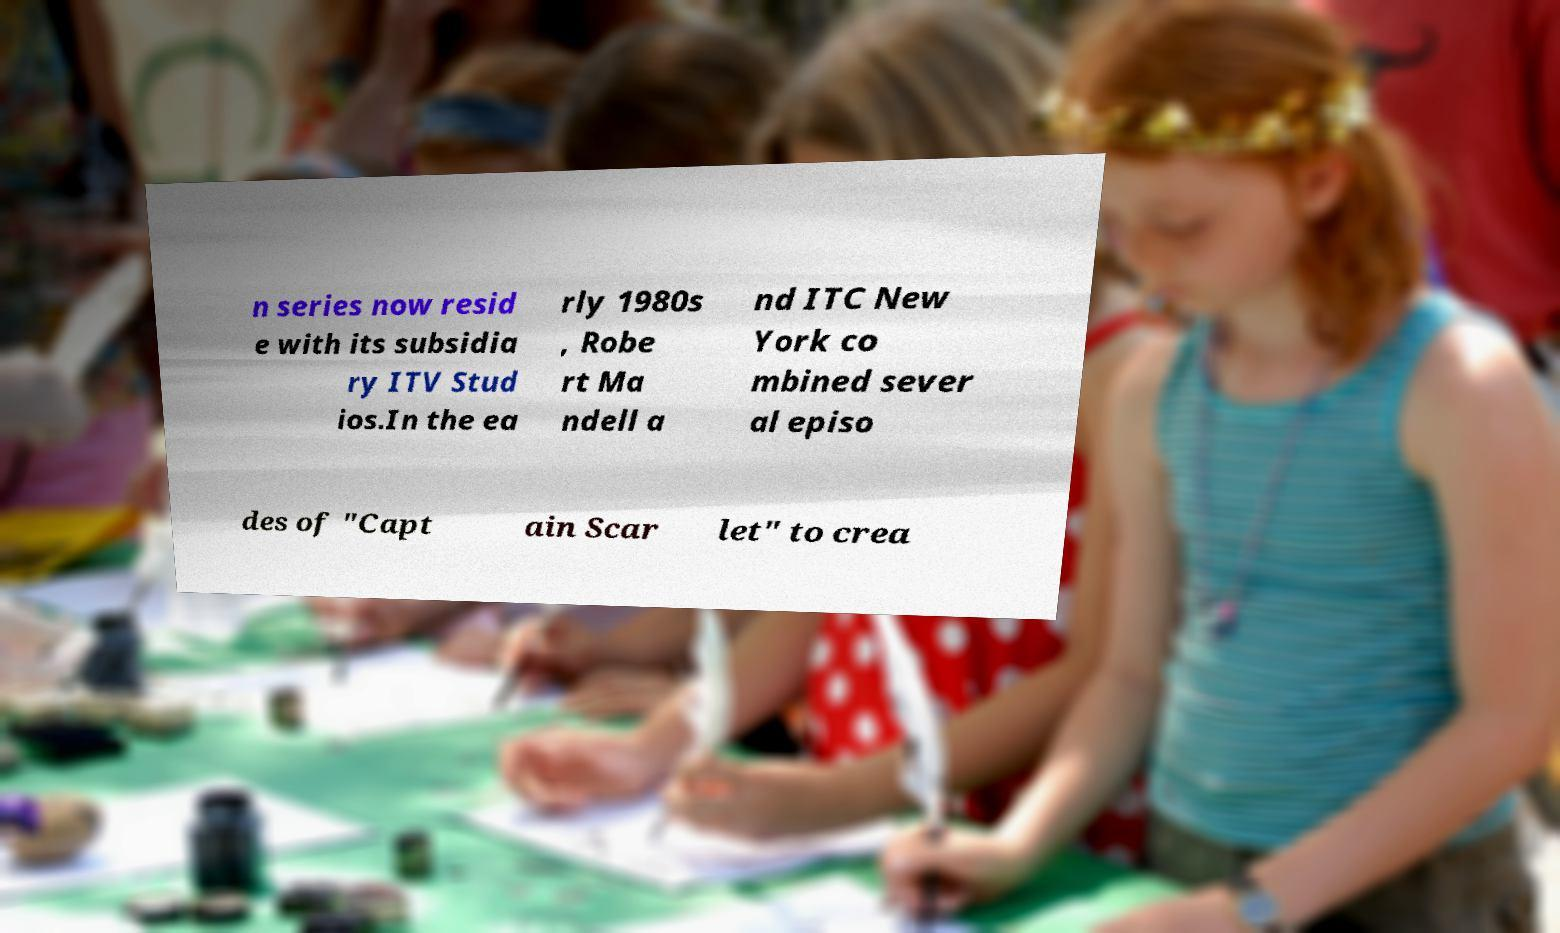Could you extract and type out the text from this image? n series now resid e with its subsidia ry ITV Stud ios.In the ea rly 1980s , Robe rt Ma ndell a nd ITC New York co mbined sever al episo des of "Capt ain Scar let" to crea 